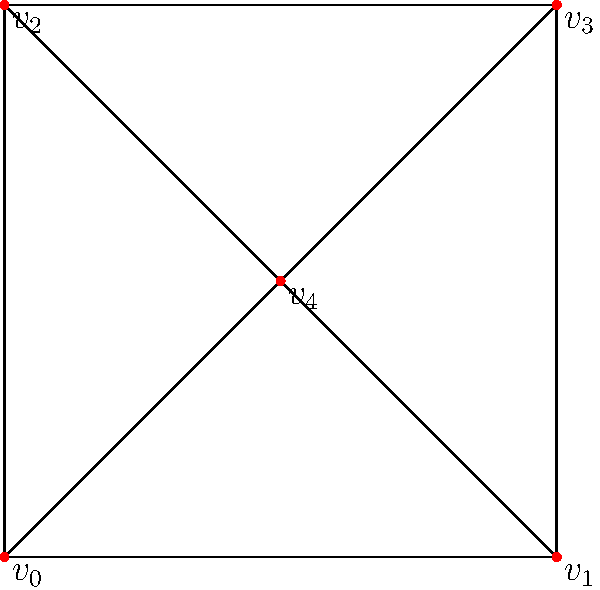In a secure communication network, the diagram represents the connections between different nodes. Determine the order of the automorphism group of this network. How many distinct ways can you relabel the nodes while preserving the connection structure? To find the order of the automorphism group, we need to analyze the symmetries of the graph:

1. Observe that $v_4$ is unique as it's the only vertex connected to all others. It must remain fixed under any automorphism.

2. The pairs $(v_0, v_2)$ and $(v_1, v_3)$ are symmetric. They can be swapped independently.

3. Let's count the possible automorphisms:
   - Keep all vertices fixed: 1 way
   - Swap $v_0$ and $v_2$: 1 way
   - Swap $v_1$ and $v_3$: 1 way
   - Swap both pairs simultaneously: 1 way

4. In total, we have $2 \times 2 = 4$ automorphisms.

5. The order of the automorphism group is therefore 4.

This means there are 4 distinct ways to relabel the nodes while preserving the connection structure of the network.
Answer: 4 